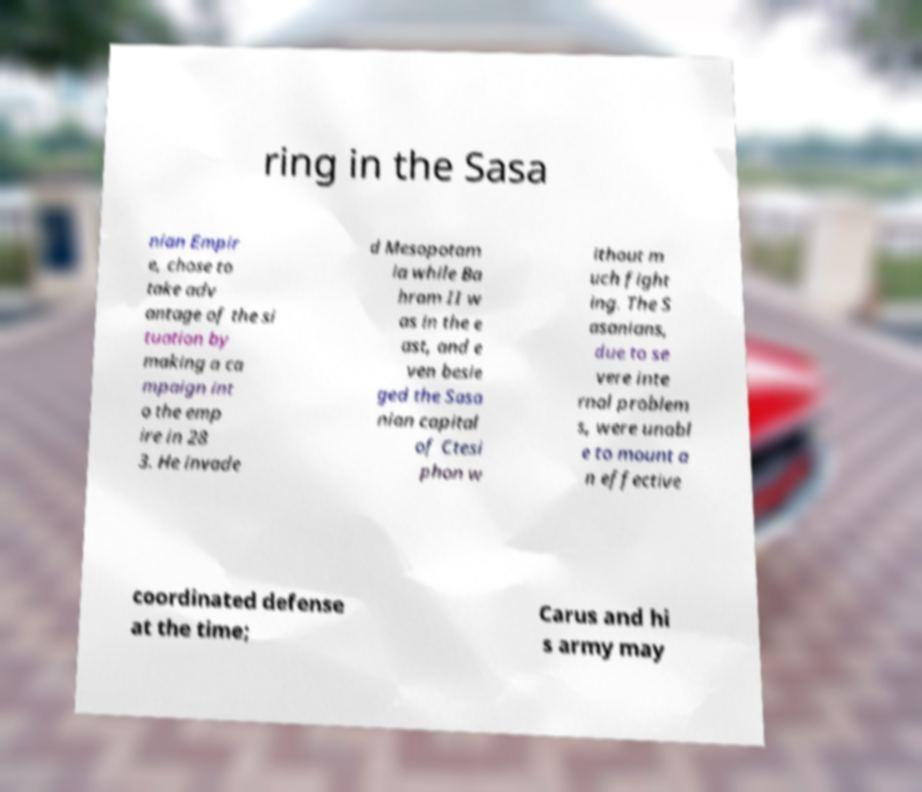Could you extract and type out the text from this image? ring in the Sasa nian Empir e, chose to take adv antage of the si tuation by making a ca mpaign int o the emp ire in 28 3. He invade d Mesopotam ia while Ba hram II w as in the e ast, and e ven besie ged the Sasa nian capital of Ctesi phon w ithout m uch fight ing. The S asanians, due to se vere inte rnal problem s, were unabl e to mount a n effective coordinated defense at the time; Carus and hi s army may 